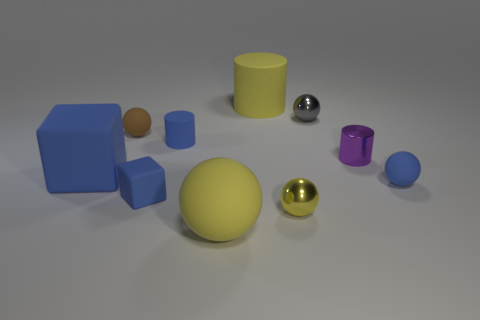Could you estimate the number of different colors present in this setup? Certainly! In this setup, there seems to be around six distinct colors: blue, yellow, red-brown, silver, gold, and purple. These shades contrast against the neutral background, highlighting the objects' diverse hues. 